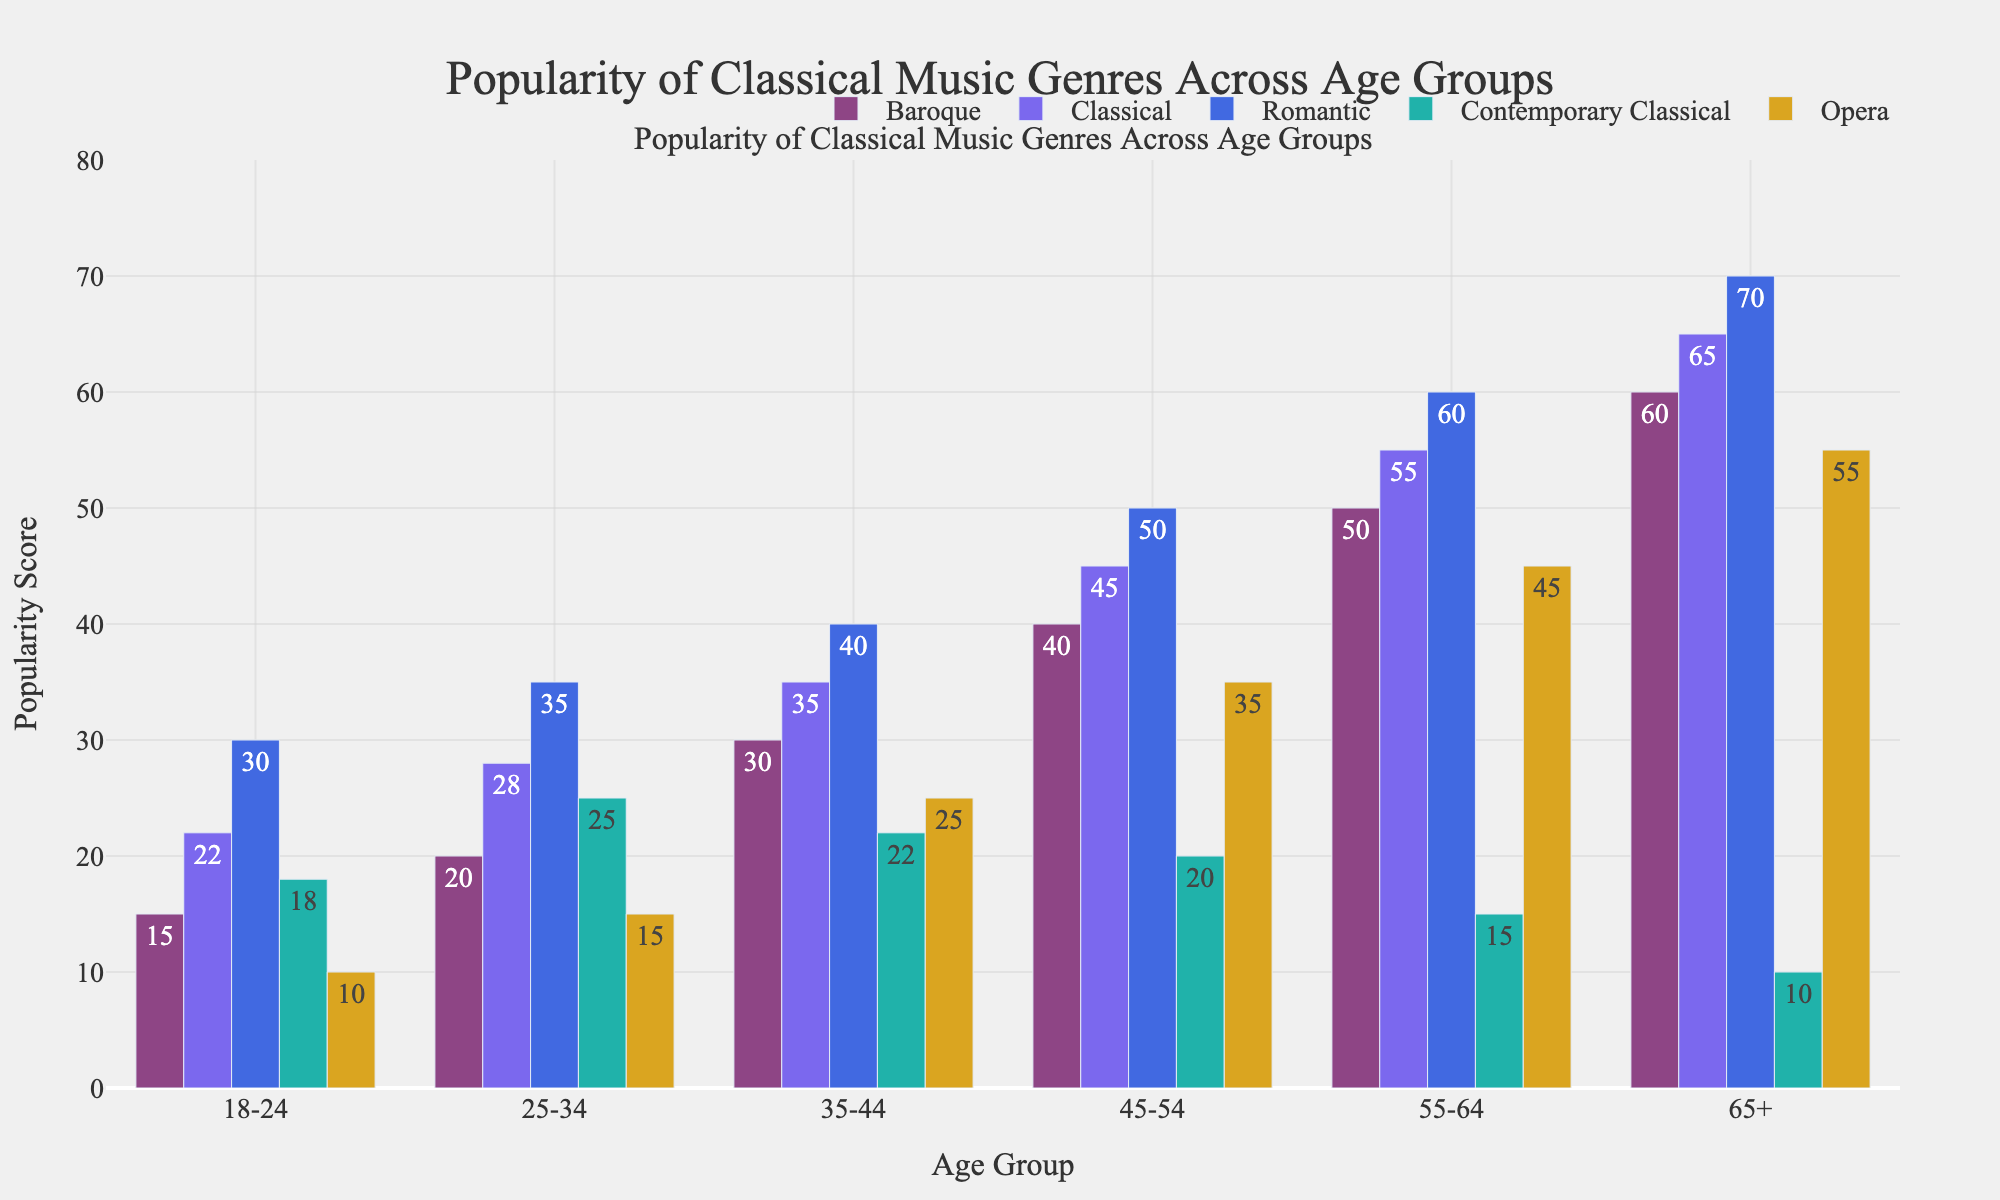Which age group prefers Baroque music the most? By examining the bar representing Baroque music across all age groups, the tallest bar corresponds to the 65+ age group.
Answer: 65+ What is the total popularity score of Contemporary Classical music across all age groups? Sum the Contemporary Classical scores: 18 (18-24) + 25 (25-34) + 22 (35-44) + 20 (45-54) + 15 (55-64) + 10 (65+). So, 18 + 25 + 22 + 20 + 15 + 10 = 110.
Answer: 110 Which genre has the highest popularity score for the 35-44 age group? By identifying the highest bar in the 35-44 age group across all genres, the highest bar corresponds to Romantic music with a score of 40.
Answer: Romantic How much more popular is Opera among the 65+ age group compared to the 18-24 age group? The Opera popularity for the 65+ group is 55 and for the 18-24 group is 10. So the difference is 55 - 10 = 45.
Answer: 45 Which age group shows the least interest in Classical music? By identifying the smallest bar for Classical music across all age groups, the smallest bar corresponds to the 18-24 age group with a score of 22.
Answer: 18-24 Compare the popularity of Romantic music between the 25-34 and the 45-54 age groups. The Romantic music score for the 25-34 age group is 35, and for the 45-54 age group, it is 50. Thus, Romantic music is more popular in the 45-54 age group by 50 - 35 = 15.
Answer: 15 Which classical music genre has the smallest range in popularity scores across all age groups? Calculate the range (max - min) for each genre:
- Baroque: 60 - 15 = 45
- Classical: 65 - 22 = 43
- Romantic: 70 - 30 = 40
- Contemporary Classical: 25 - 10 = 15
- Opera: 55 - 10 = 45
The smallest range is for Contemporary Classical with a range of 15.
Answer: Contemporary Classical What is the combined popularity score for Baroque and Opera among the 55-64 age group? Sum the scores for Baroque and Opera in the 55-64 age group: 50 (Baroque) + 45 (Opera). So, 50 + 45 = 95.
Answer: 95 Which age group has the highest overall average popularity score across all genres? Calculate the average for each age group:
- 18-24: (15 + 22 + 30 + 18 + 10) / 5 = 95 / 5 = 19
- 25-34: (20 + 28 + 35 + 25 + 15) / 5 = 123 / 5 = 24.6
- 35-44: (30 + 35 + 40 + 22 + 25) / 5 = 152 / 5 = 30.4
- 45-54: (40 + 45 + 50 + 20 + 35) / 5 = 190 / 5 = 38
- 55-64: (50 + 55 + 60 + 15 + 45) / 5 = 225 / 5 = 45
- 65+: (60 + 65 + 70 + 10 + 55) / 5 = 260 / 5 = 52
The highest average score is for the 65+ age group with an average of 52.
Answer: 65+ 